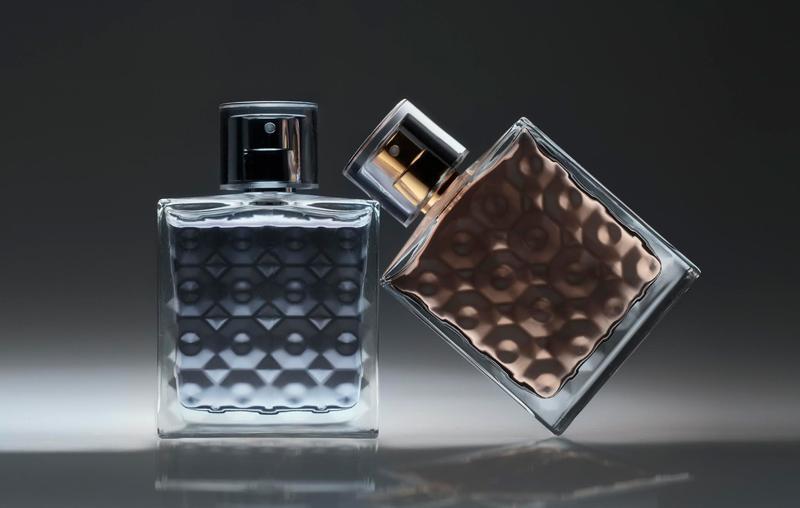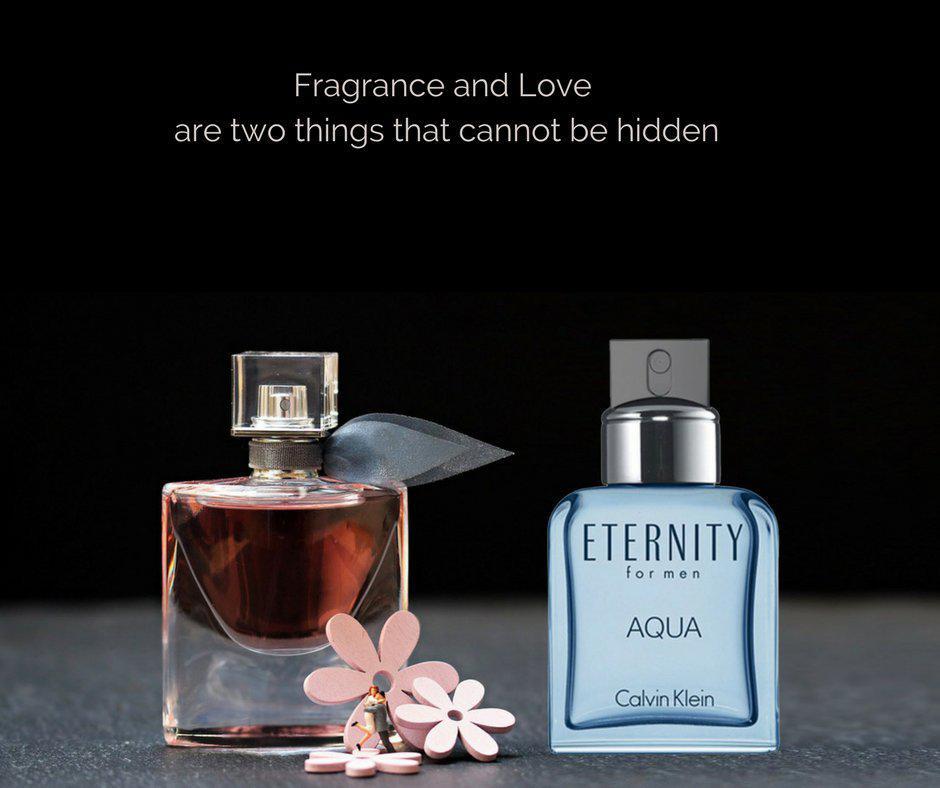The first image is the image on the left, the second image is the image on the right. Analyze the images presented: Is the assertion "An image includes a fragrance bottle with a rounded base ad round cap." valid? Answer yes or no. No. 